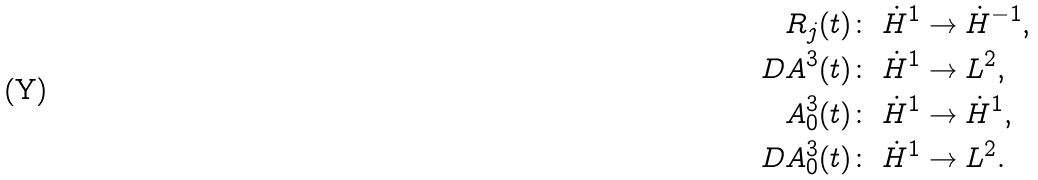Convert formula to latex. <formula><loc_0><loc_0><loc_500><loc_500>R _ { j } ( t ) \colon & \ \dot { H } ^ { 1 } \to \dot { H } ^ { - 1 } , \\ \ D A ^ { 3 } ( t ) \colon & \ \dot { H } ^ { 1 } \to L ^ { 2 } , \\ A _ { 0 } ^ { 3 } ( t ) \colon & \ \dot { H } ^ { 1 } \to \dot { H } ^ { 1 } , \\ \ D A _ { 0 } ^ { 3 } ( t ) \colon & \ \dot { H } ^ { 1 } \to L ^ { 2 } .</formula> 